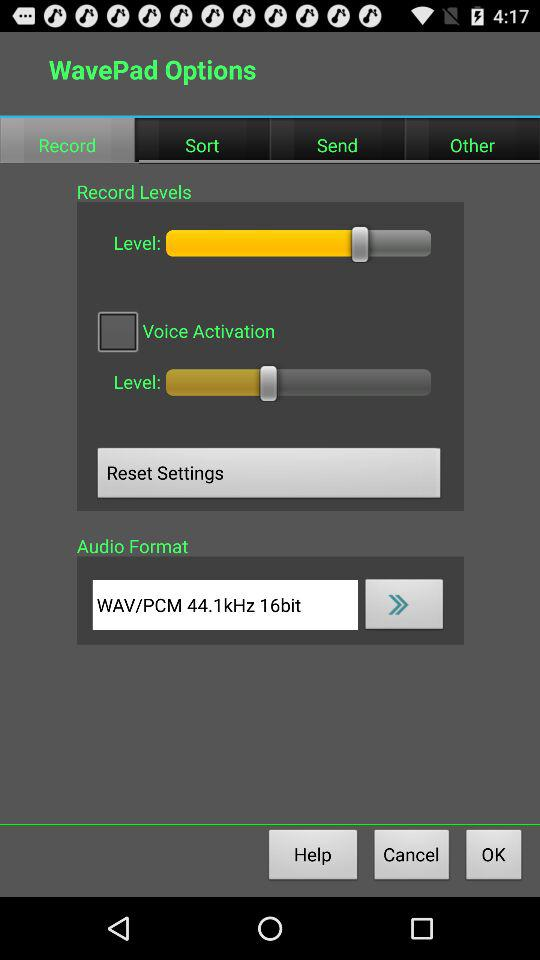Which tab has been selected? The selected tab is "Record". 